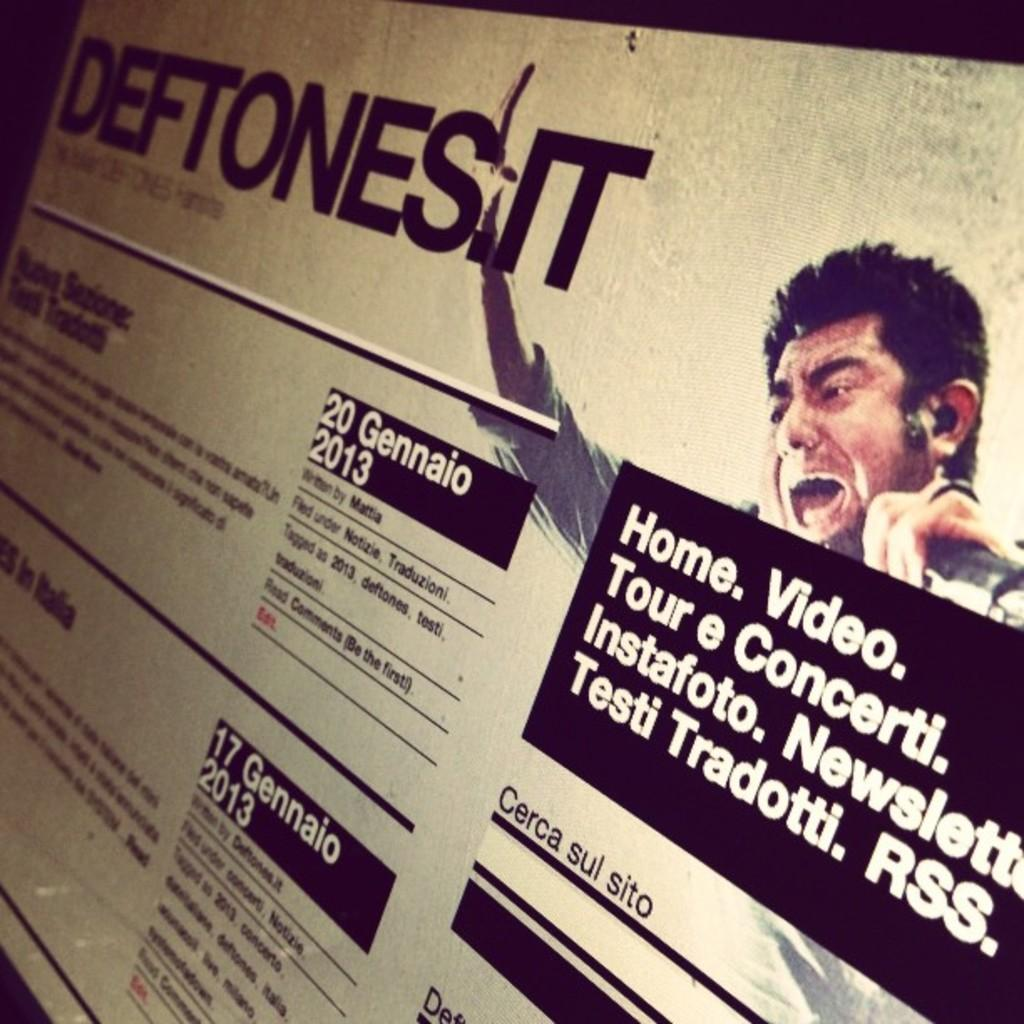What type of image is being described? The image is a poster. Who or what is depicted in the poster? There is a man in the poster. Are there any words or phrases on the poster? Yes, there is text on the poster. How many lumber pieces are stacked next to the man in the poster? There are no lumber pieces present in the poster; it only features a man and text. What type of roll is being used by the man in the poster? There is no roll visible in the poster; the man is not performing any actions or using any objects. 